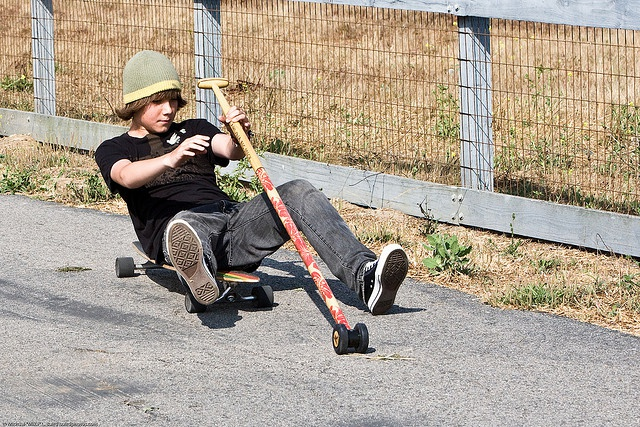Describe the objects in this image and their specific colors. I can see people in tan, black, gray, white, and darkgray tones and skateboard in tan, black, gray, darkgray, and lightgray tones in this image. 